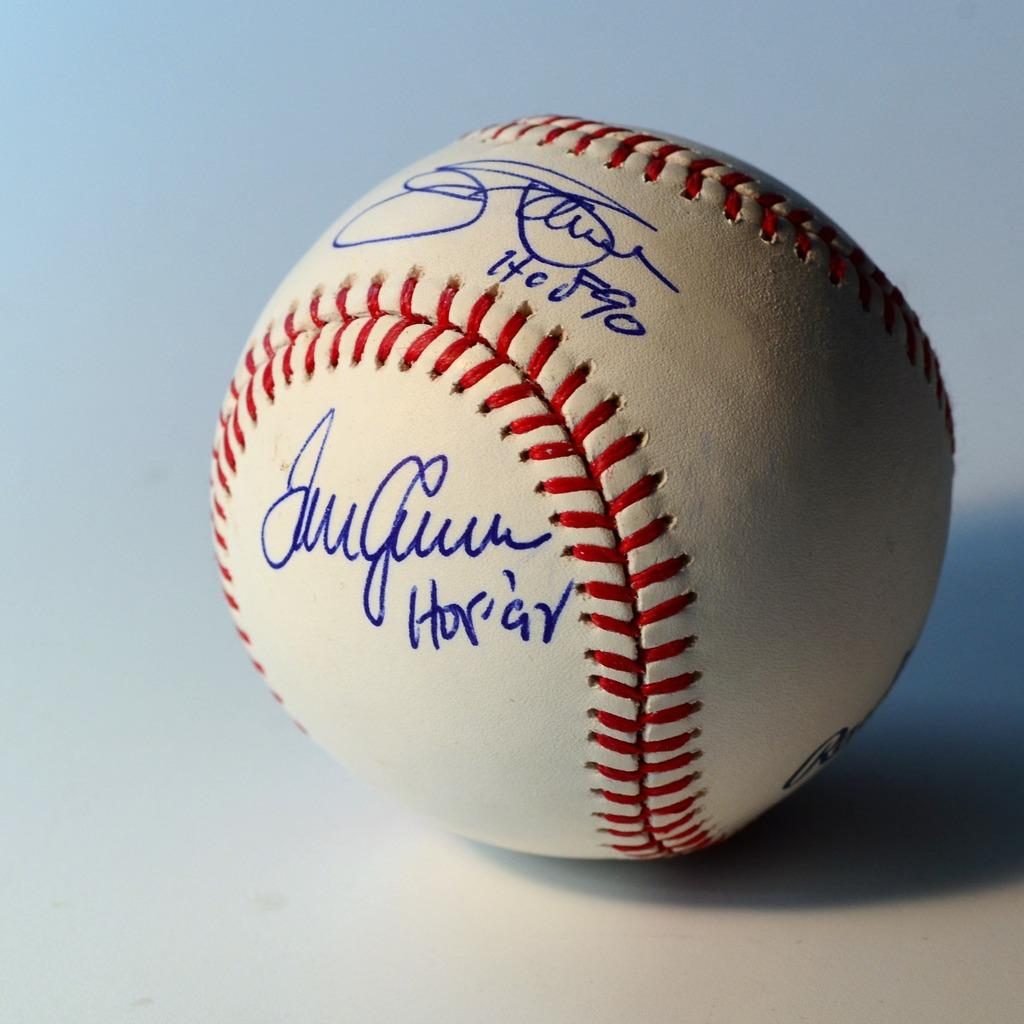What is the main subject in the center of the image? There is a ball in the center of the image. What can be observed about the ball's location? The ball is on a surface. Are there any additional details visible on the ball? Yes, there is text on the ball. What type of rice is being served on the bed in the image? There is no rice or bed present in the image; it only features a ball with text on it. 